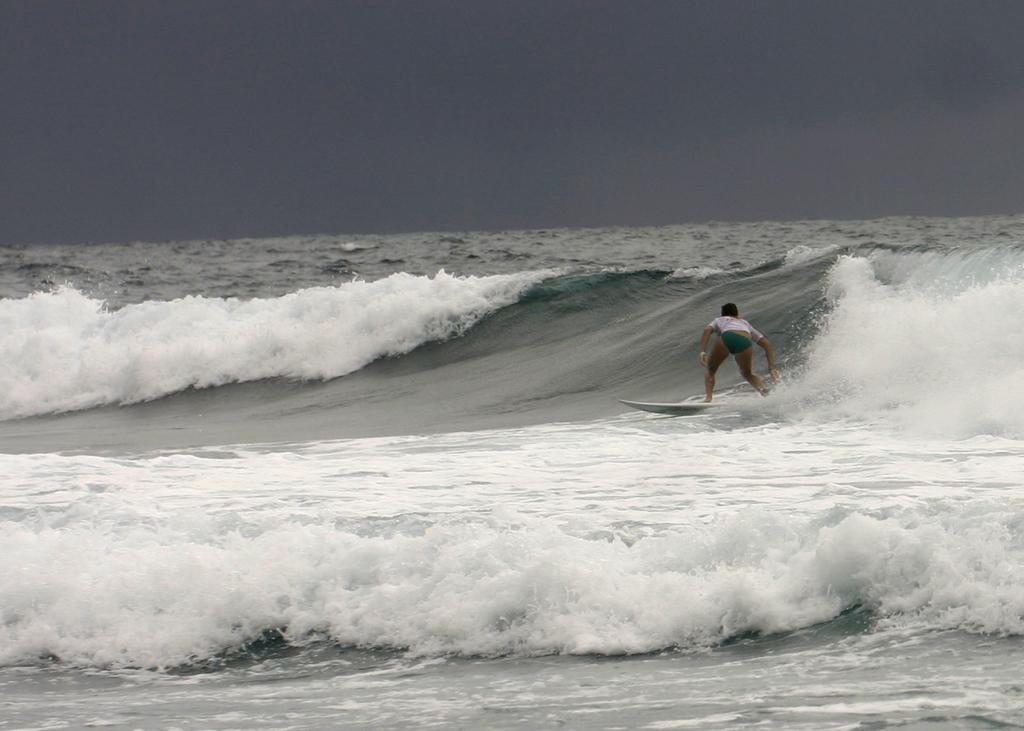What is the main subject of the image? There is a person in the image. What is the person wearing? The person is wearing clothes. What activity is the person engaged in? The person is surfing on the sea. What can be seen in the background of the image? There is a sky visible at the top of the image. What is the person's interest in ladybugs while surfing in the image? There is no mention of ladybugs in the image, so it is impossible to determine the person's interest in them while surfing. 